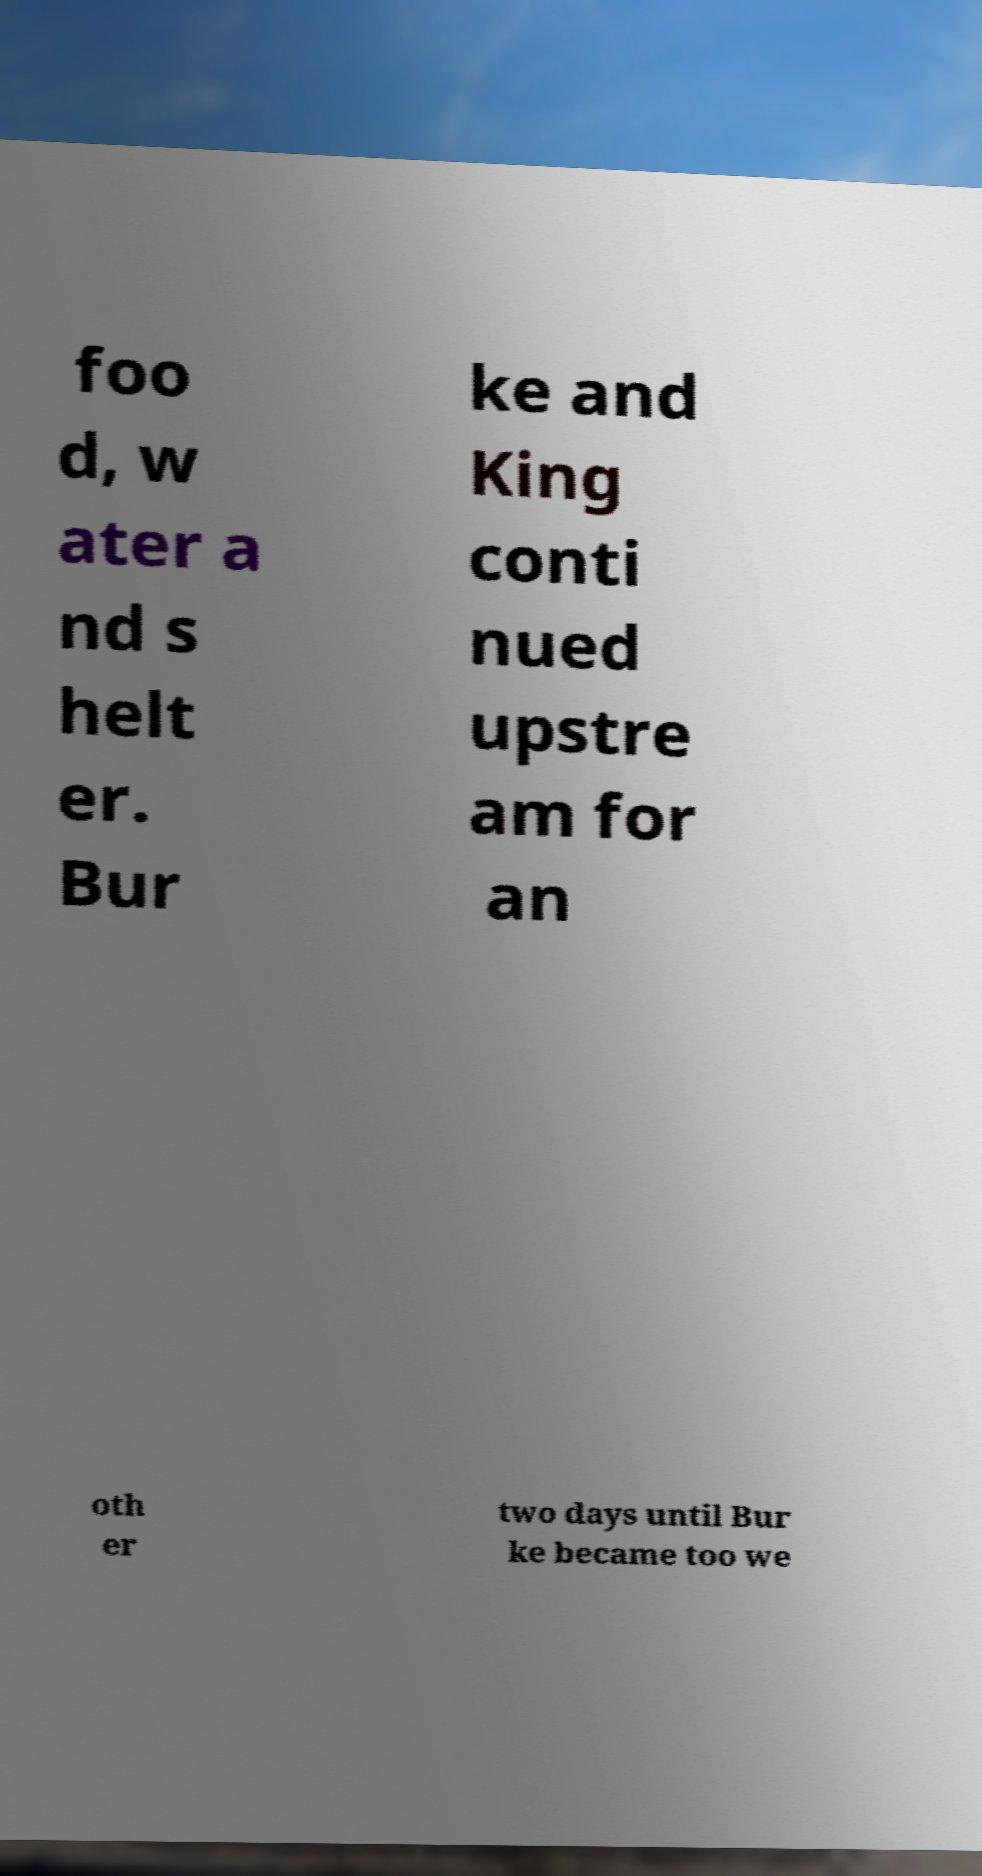I need the written content from this picture converted into text. Can you do that? foo d, w ater a nd s helt er. Bur ke and King conti nued upstre am for an oth er two days until Bur ke became too we 